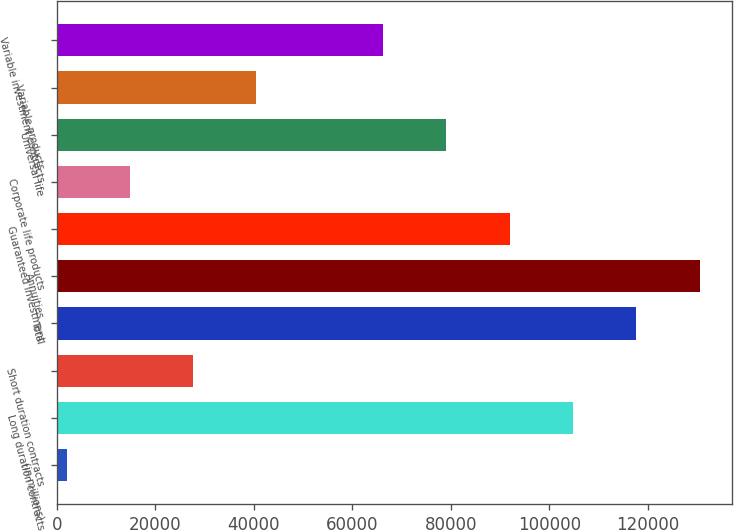<chart> <loc_0><loc_0><loc_500><loc_500><bar_chart><fcel>(in millions)<fcel>Long duration contracts<fcel>Short duration contracts<fcel>Total<fcel>Annuities<fcel>Guaranteed investment<fcel>Corporate life products<fcel>Universal life<fcel>Variable products<fcel>Variable investment contracts<nl><fcel>2004<fcel>104820<fcel>27708<fcel>117672<fcel>130524<fcel>91968<fcel>14856<fcel>79116<fcel>40560<fcel>66264<nl></chart> 